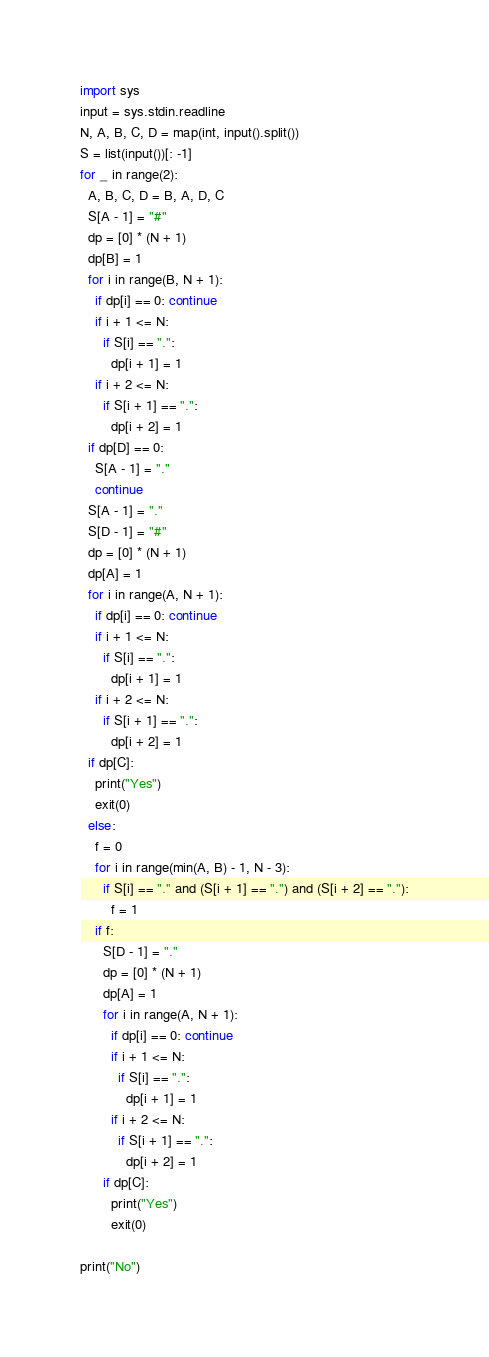Convert code to text. <code><loc_0><loc_0><loc_500><loc_500><_Python_>import sys
input = sys.stdin.readline
N, A, B, C, D = map(int, input().split())
S = list(input())[: -1]
for _ in range(2):
  A, B, C, D = B, A, D, C
  S[A - 1] = "#"
  dp = [0] * (N + 1)
  dp[B] = 1
  for i in range(B, N + 1):
    if dp[i] == 0: continue
    if i + 1 <= N:
      if S[i] == ".":
        dp[i + 1] = 1
    if i + 2 <= N:
      if S[i + 1] == ".":
        dp[i + 2] = 1
  if dp[D] == 0:
    S[A - 1] = "."
    continue
  S[A - 1] = "."
  S[D - 1] = "#"
  dp = [0] * (N + 1)
  dp[A] = 1
  for i in range(A, N + 1):
    if dp[i] == 0: continue
    if i + 1 <= N:
      if S[i] == ".":
        dp[i + 1] = 1
    if i + 2 <= N:
      if S[i + 1] == ".":
        dp[i + 2] = 1
  if dp[C]:
    print("Yes")
    exit(0)
  else:
    f = 0
    for i in range(min(A, B) - 1, N - 3):
      if S[i] == "." and (S[i + 1] == ".") and (S[i + 2] == "."):
        f = 1
    if f:
      S[D - 1] = "."
      dp = [0] * (N + 1)
      dp[A] = 1
      for i in range(A, N + 1):
        if dp[i] == 0: continue
        if i + 1 <= N:
          if S[i] == ".":
            dp[i + 1] = 1
        if i + 2 <= N:
          if S[i + 1] == ".":
            dp[i + 2] = 1
      if dp[C]:
        print("Yes")
        exit(0)
    
print("No")</code> 